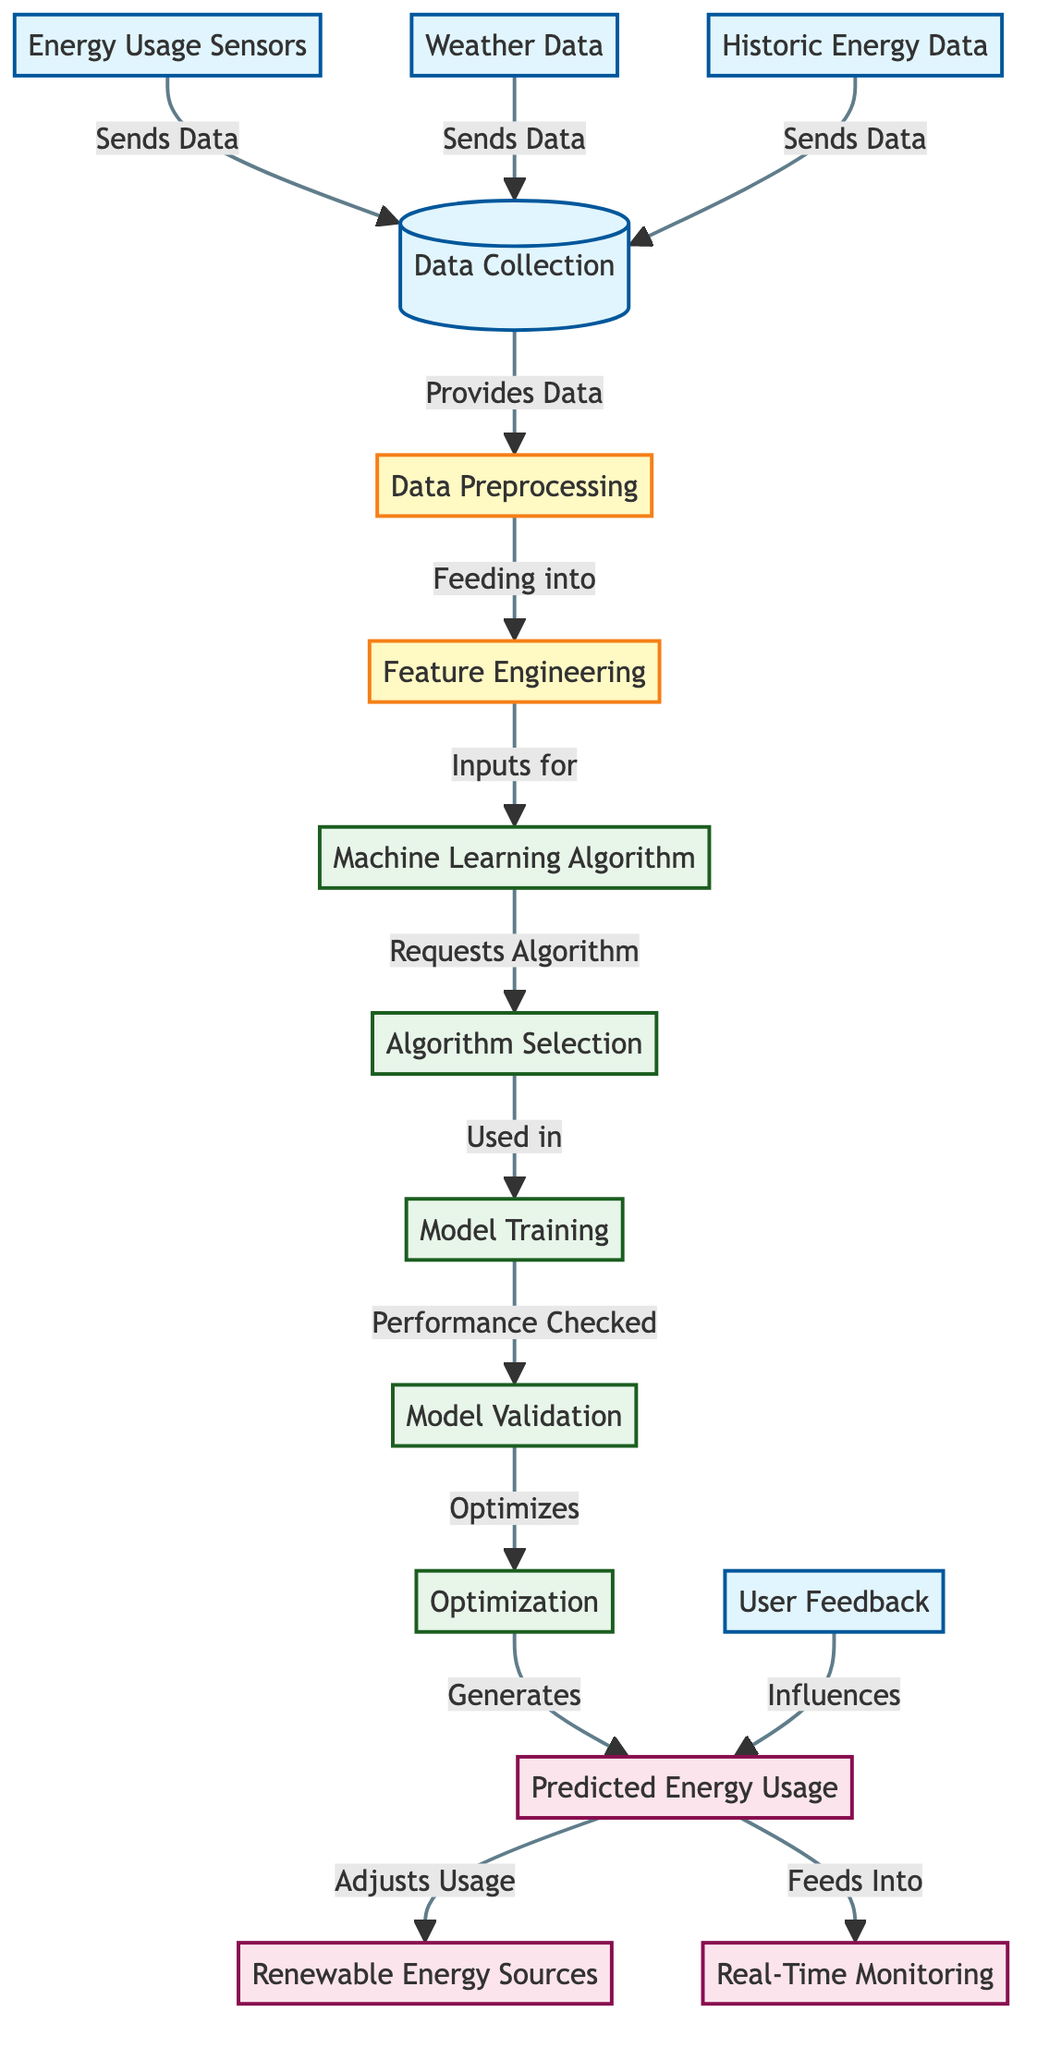What is the starting point of data collection in the diagram? The starting point of data collection in the diagram is represented by the "Energy Usage Sensors," "Weather Data," and "Historic Energy Data," which all feed data into the "Data Collection" node.
Answer: Energy Usage Sensors How many main process nodes are present in the diagram? The diagram contains four main process nodes: "Data Preprocessing," "Feature Engineering," "Machine Learning Algorithm," and "Optimization." Counting these nodes gives us four.
Answer: Four Which node produces the "Predicted Energy Usage"? The "Predicted Energy Usage" is generated by the "Optimization" node, as indicated by the flow from the "Optimization" node to "Predicted Energy Usage."
Answer: Optimization What type of data influences the "Predicted Energy Usage"? The "Predicted Energy Usage" is influenced by "User Feedback," which directly impacts the prediction model. This feedback serves as input, helping to refine the usage predictions.
Answer: User Feedback Where does the "Real-Time Monitoring" node receive its input from? The "Real-Time Monitoring" node receives its input from the "Predicted Energy Usage" node, which means that the monitoring is based on the predictions made in that previous step.
Answer: Predicted Energy Usage What stage comes after "Model Validation" in the machine learning process? After "Model Validation," the next stage in the machine learning process is "Optimization," where the model's performance is optimized based on validation results.
Answer: Optimization Which nodes are responsible for providing data to the "Data Collection" node? The nodes responsible for providing data to the "Data Collection" node are "Energy Usage Sensors," "Weather Data," and "Historic Energy Data." These nodes all send their respective data to the "Data Collection."
Answer: Energy Usage Sensors, Weather Data, Historic Energy Data What is the final output of the machine learning process represented in the diagram? The final outputs of the machine learning process are "Predicted Energy Usage," "Renewable Energy Sources," and "Real-Time Monitoring." These three outputs represent the results generated by the optimization stages.
Answer: Predicted Energy Usage, Renewable Energy Sources, Real-Time Monitoring How is "Algorithm Selection" related to the overall machine learning process here? "Algorithm Selection" is part of the machine learning process that requests algorithms for the next stage of model training. It serves as a critical step that determines which algorithm will be used for training the model.
Answer: Machine Learning Algorithm 